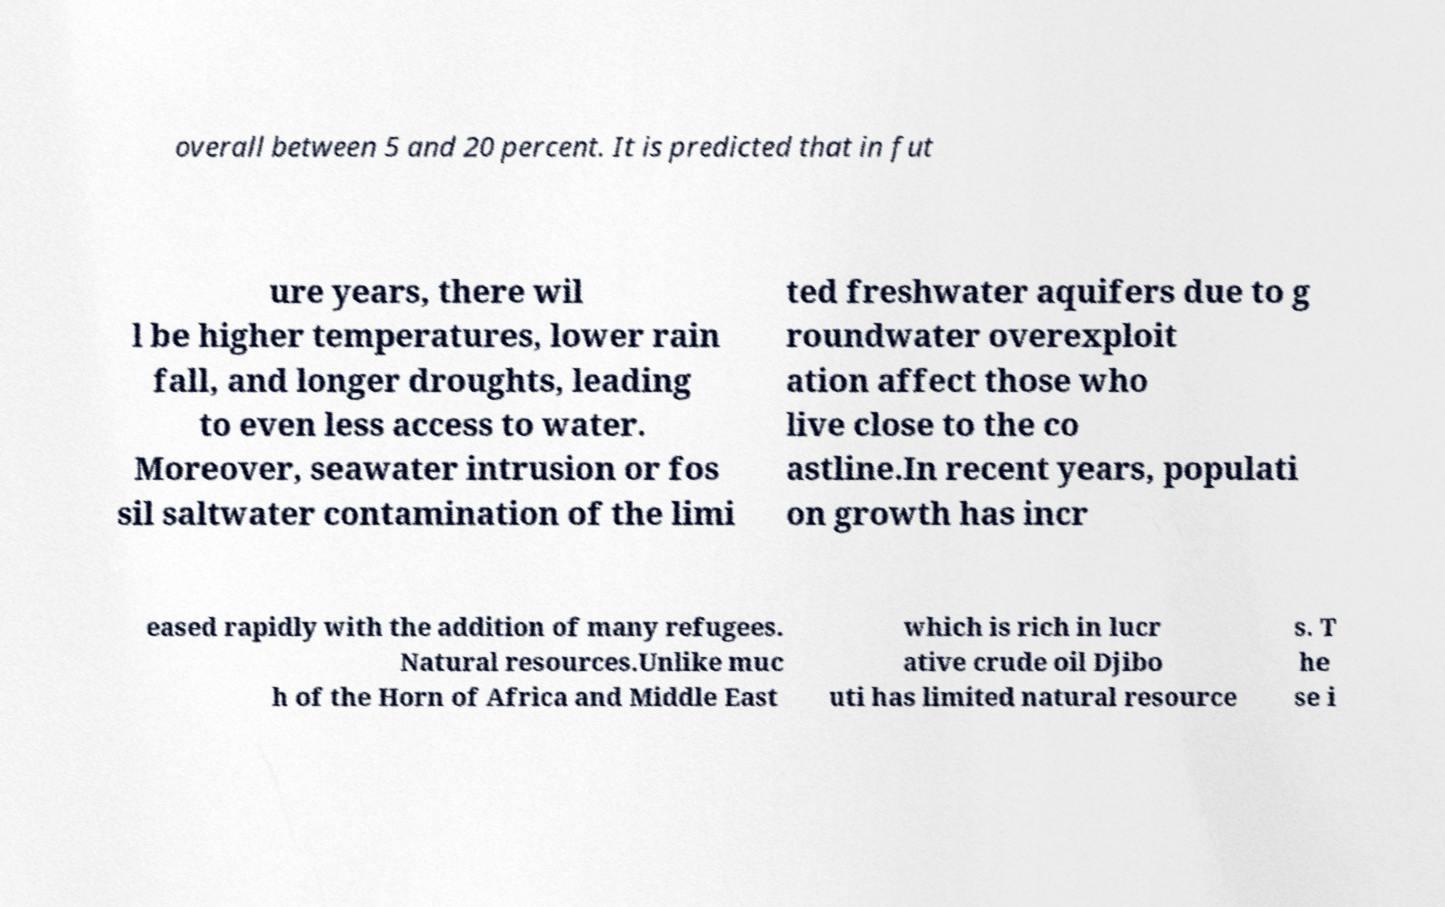Can you accurately transcribe the text from the provided image for me? overall between 5 and 20 percent. It is predicted that in fut ure years, there wil l be higher temperatures, lower rain fall, and longer droughts, leading to even less access to water. Moreover, seawater intrusion or fos sil saltwater contamination of the limi ted freshwater aquifers due to g roundwater overexploit ation affect those who live close to the co astline.In recent years, populati on growth has incr eased rapidly with the addition of many refugees. Natural resources.Unlike muc h of the Horn of Africa and Middle East which is rich in lucr ative crude oil Djibo uti has limited natural resource s. T he se i 